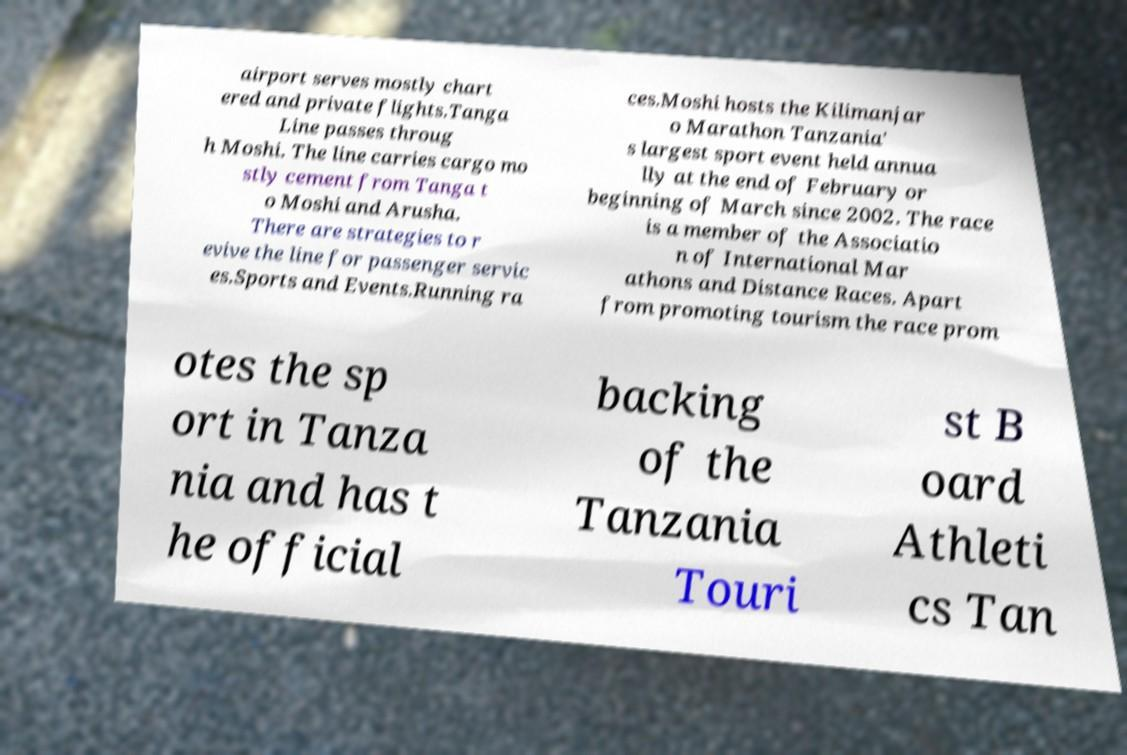Can you accurately transcribe the text from the provided image for me? airport serves mostly chart ered and private flights.Tanga Line passes throug h Moshi. The line carries cargo mo stly cement from Tanga t o Moshi and Arusha. There are strategies to r evive the line for passenger servic es.Sports and Events.Running ra ces.Moshi hosts the Kilimanjar o Marathon Tanzania' s largest sport event held annua lly at the end of February or beginning of March since 2002. The race is a member of the Associatio n of International Mar athons and Distance Races. Apart from promoting tourism the race prom otes the sp ort in Tanza nia and has t he official backing of the Tanzania Touri st B oard Athleti cs Tan 